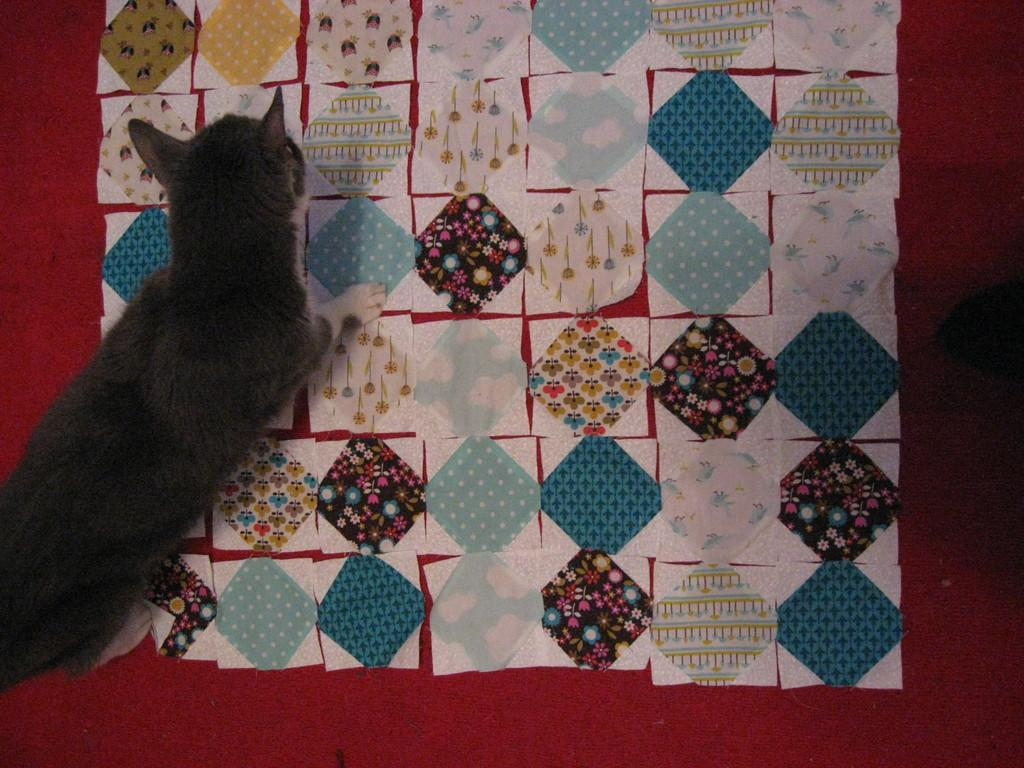What type of animal is present in the image? There is a cat in the image. Where is the cat located in the image? The cat is on a mat. What type of knowledge does the cat possess about thunder in the image? There is no mention of thunder in the image, and therefore no information about the cat's knowledge of it. How many toes can be seen on the cat's paws in the image? The image does not provide a close enough view to count the cat's toes on its paws. 